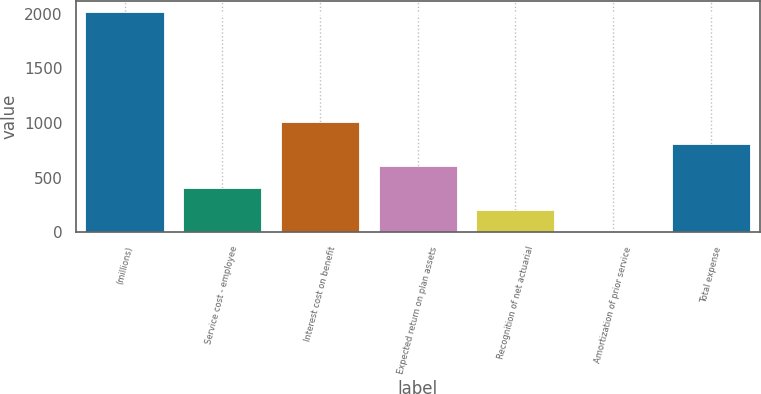Convert chart. <chart><loc_0><loc_0><loc_500><loc_500><bar_chart><fcel>(millions)<fcel>Service cost - employee<fcel>Interest cost on benefit<fcel>Expected return on plan assets<fcel>Recognition of net actuarial<fcel>Amortization of prior service<fcel>Total expense<nl><fcel>2013<fcel>402.84<fcel>1006.65<fcel>604.11<fcel>201.57<fcel>0.3<fcel>805.38<nl></chart> 